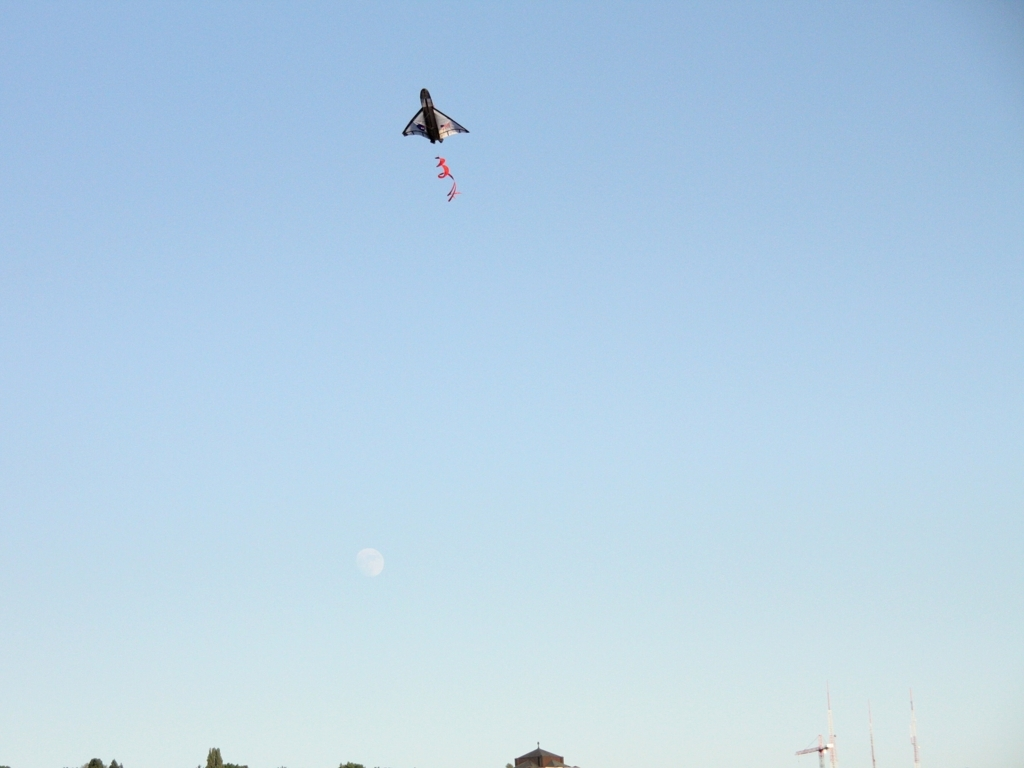Is this photo taken during a specific time of day? Judging by the soft light and presence of the moon visible in the sky, the photo likely was taken either during early morning or late evening. This time of day, known as the 'golden hour,' is characterized by warm, diffused sunlight that is favorable for photography. Does the presence of the moon in the sky have any significance for kite flying? While the moon's presence doesn't directly affect the physical activity of kite flying, it can add a sense of serenity and beauty to the experience. Moonlit evenings can make for a unique and memorable time to fly kites, provided there is sufficient light and wind. 